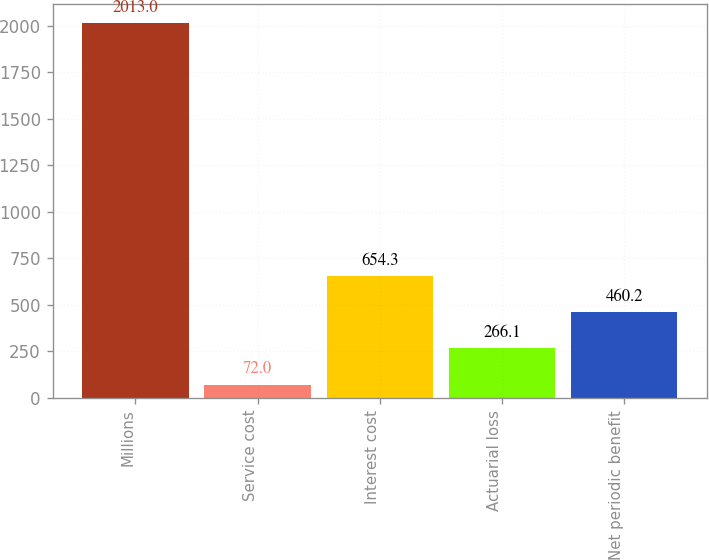Convert chart to OTSL. <chart><loc_0><loc_0><loc_500><loc_500><bar_chart><fcel>Millions<fcel>Service cost<fcel>Interest cost<fcel>Actuarial loss<fcel>Net periodic benefit<nl><fcel>2013<fcel>72<fcel>654.3<fcel>266.1<fcel>460.2<nl></chart> 